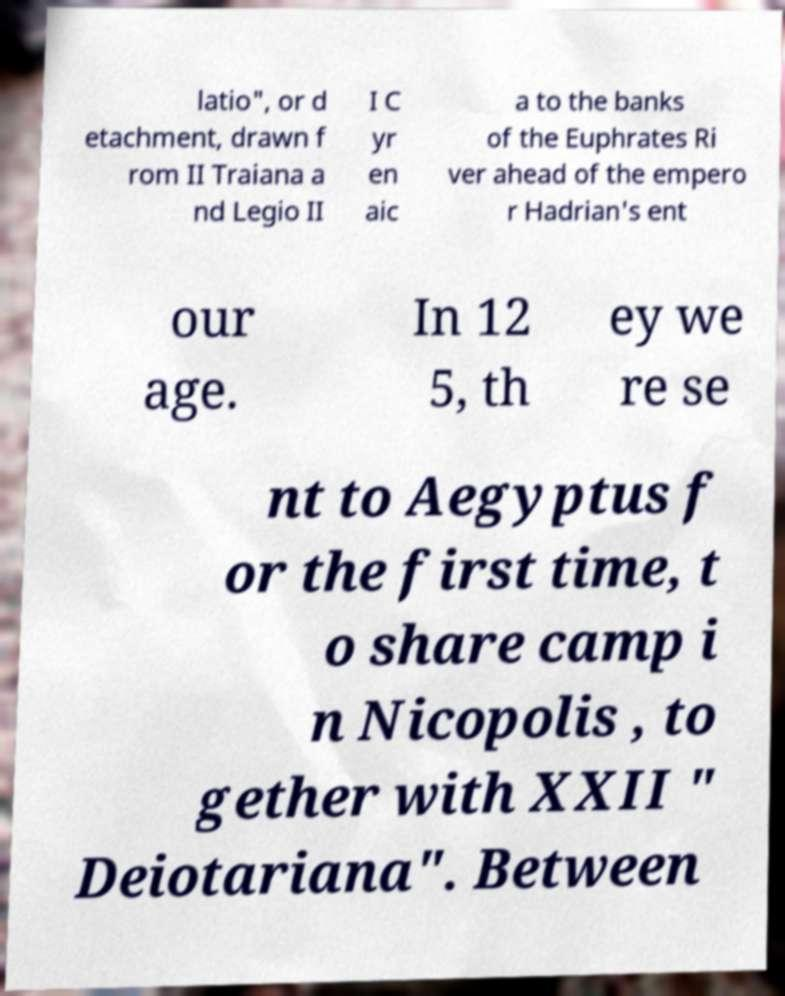There's text embedded in this image that I need extracted. Can you transcribe it verbatim? latio", or d etachment, drawn f rom II Traiana a nd Legio II I C yr en aic a to the banks of the Euphrates Ri ver ahead of the empero r Hadrian's ent our age. In 12 5, th ey we re se nt to Aegyptus f or the first time, t o share camp i n Nicopolis , to gether with XXII " Deiotariana". Between 